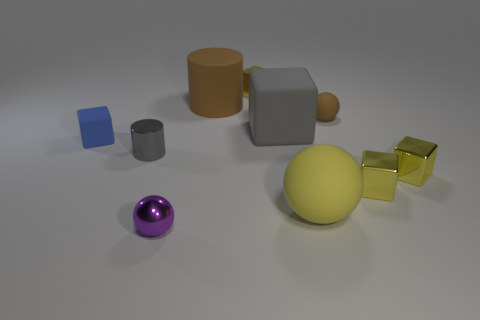Subtract all yellow blocks. How many were subtracted if there are1yellow blocks left? 2 Subtract all large blocks. How many blocks are left? 4 Subtract all purple spheres. How many yellow blocks are left? 3 Subtract all cylinders. How many objects are left? 8 Subtract all blue blocks. How many blocks are left? 4 Add 6 yellow metal cubes. How many yellow metal cubes exist? 9 Subtract 1 purple balls. How many objects are left? 9 Subtract all purple cubes. Subtract all gray cylinders. How many cubes are left? 5 Subtract all small brown rubber spheres. Subtract all brown rubber balls. How many objects are left? 8 Add 3 blue matte cubes. How many blue matte cubes are left? 4 